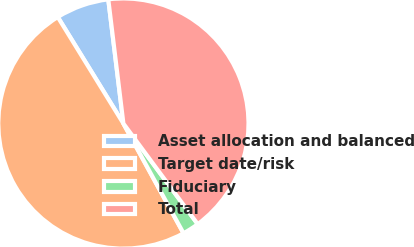<chart> <loc_0><loc_0><loc_500><loc_500><pie_chart><fcel>Asset allocation and balanced<fcel>Target date/risk<fcel>Fiduciary<fcel>Total<nl><fcel>6.86%<fcel>49.19%<fcel>2.15%<fcel>41.8%<nl></chart> 